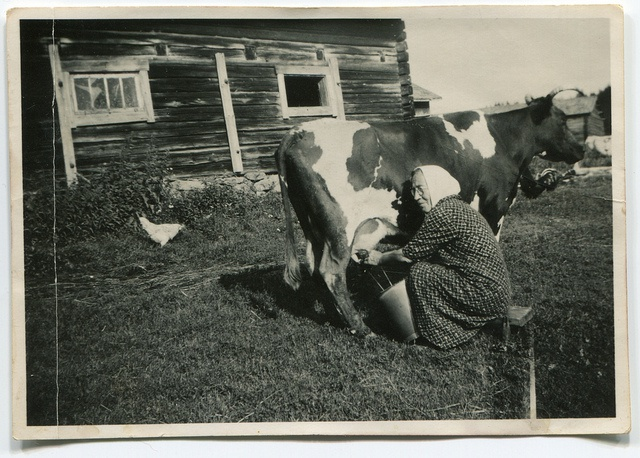Describe the objects in this image and their specific colors. I can see cow in white, black, gray, lightgray, and darkgray tones, people in white, black, gray, darkgray, and lightgray tones, and bird in white, lightgray, darkgray, and gray tones in this image. 